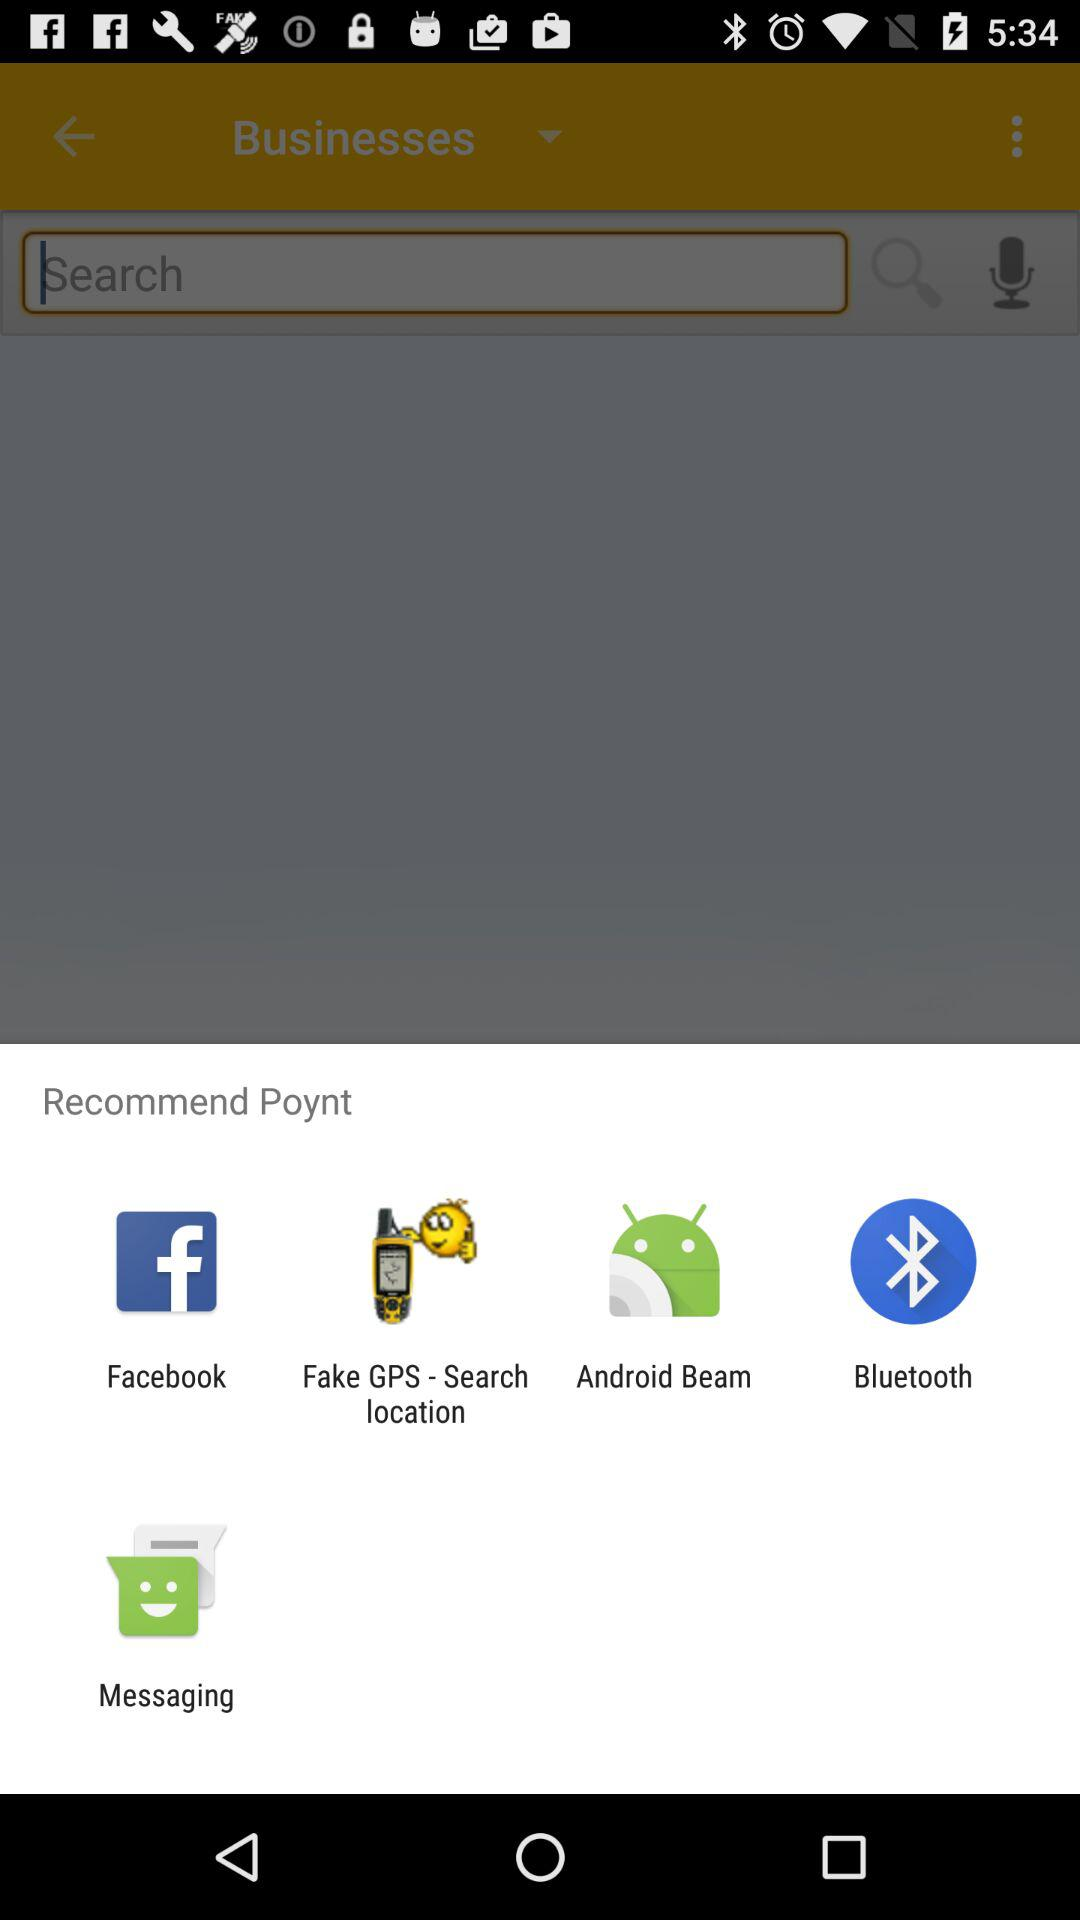What applications can be used to recommend "Poynt"? The applications used to recommend "Poynt" are "Facebook", "Fake GPS - Search location", "Android Beam", "Bluetooth" and "Messaging". 